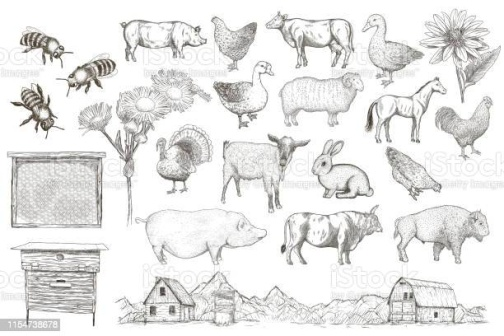Draw a connection between the farm's animals and their roles in traditional myths and folklore. Absolutely! Many of the animals depicted in the image are deeply rooted in traditional myths and folklore, each carrying unique symbolic meanings.

In many cultures, bees are often seen as messengers between the earthly and divine realms, symbolizing hard work, cooperation, and the community. The cow represents abundance, fertility, and maternal nurturing, commonly appearing in myths as a sacred provider of life-sustaining milk. Chickens are often linked with the dawn and new beginnings due to their crowing at the break of day, symbolizing vigilance and resurrection.

Pigs, despite their common perception, are often symbols of luck, prosperity, and abundance in various cultures, such as in Chinese folklore, where the pig is one of the twelve zodiac animals. Sheep are symbols of innocence, warmth, and pastoral life, often depicted alongside shepherds in religious and mythical stories. The goose, with its migratory pattern, symbolizes loyalty, fidelity, and the journey of the soul in several myths.

These mythical associations add a layer of depth to the everyday roles these animals play on a farm, linking them to the rich tapestry of human culture and collective consciousness. 